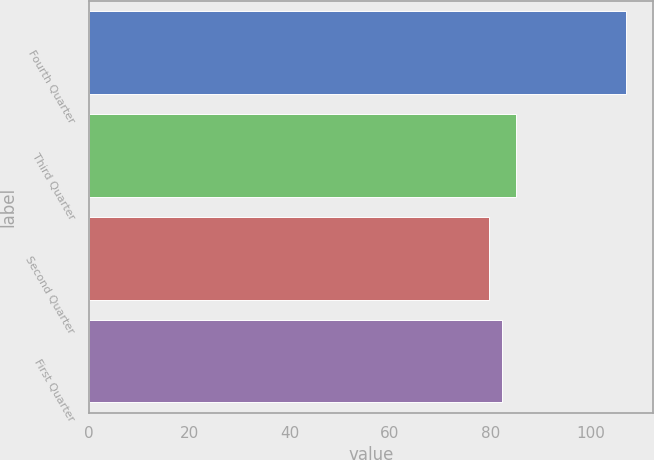Convert chart to OTSL. <chart><loc_0><loc_0><loc_500><loc_500><bar_chart><fcel>Fourth Quarter<fcel>Third Quarter<fcel>Second Quarter<fcel>First Quarter<nl><fcel>107.1<fcel>85.19<fcel>79.71<fcel>82.45<nl></chart> 